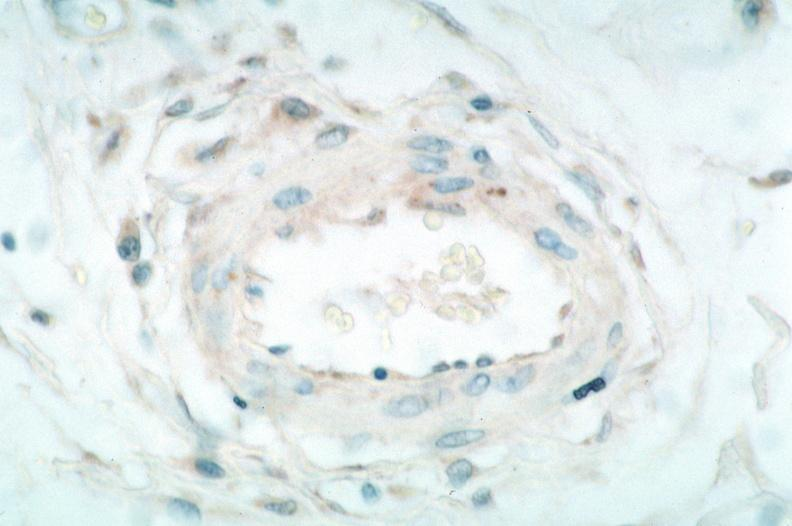what does this image show?
Answer the question using a single word or phrase. Vasculitis 